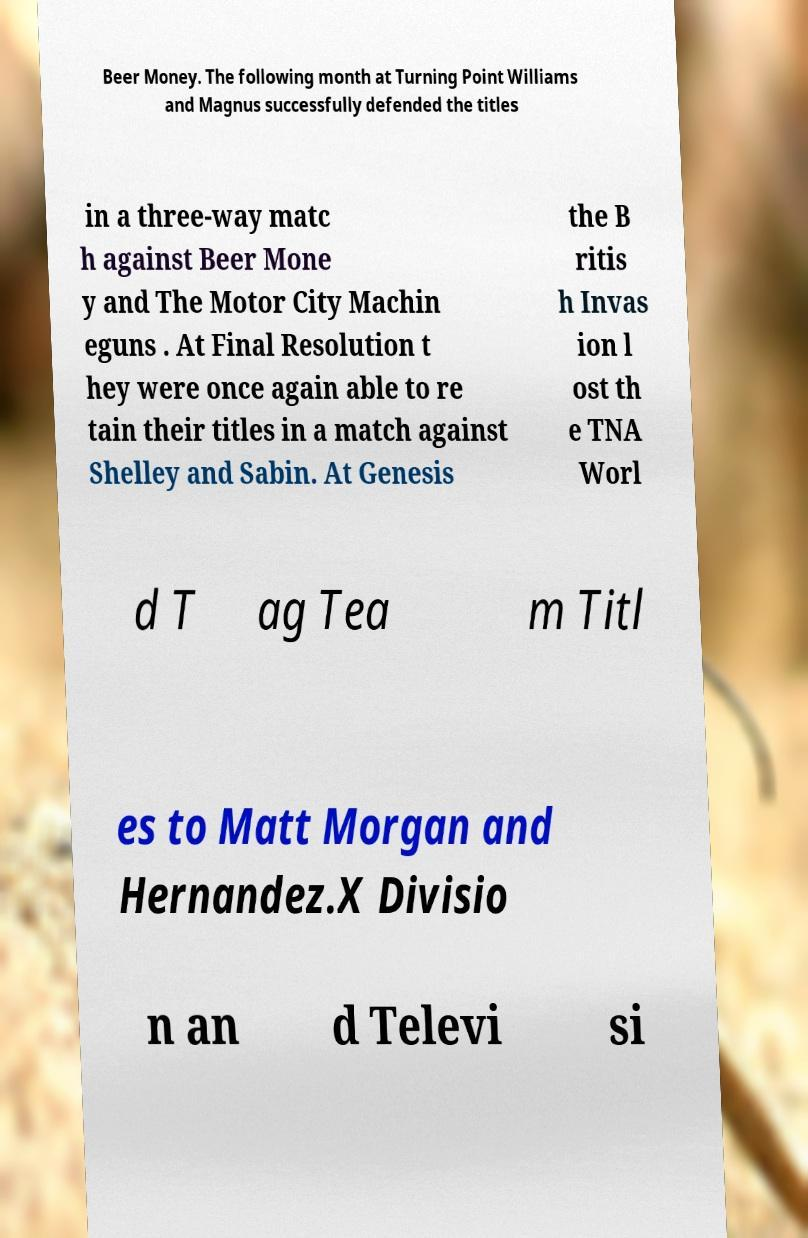There's text embedded in this image that I need extracted. Can you transcribe it verbatim? Beer Money. The following month at Turning Point Williams and Magnus successfully defended the titles in a three-way matc h against Beer Mone y and The Motor City Machin eguns . At Final Resolution t hey were once again able to re tain their titles in a match against Shelley and Sabin. At Genesis the B ritis h Invas ion l ost th e TNA Worl d T ag Tea m Titl es to Matt Morgan and Hernandez.X Divisio n an d Televi si 